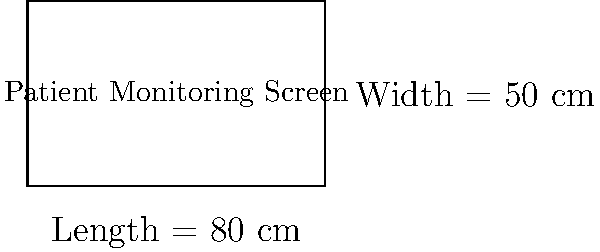A rectangular patient monitoring screen has a length of 80 cm and a width of 50 cm. Calculate the perimeter of the screen in meters. To calculate the perimeter of the rectangular patient monitoring screen, we need to follow these steps:

1. Recall the formula for the perimeter of a rectangle:
   $P = 2l + 2w$, where $P$ is the perimeter, $l$ is the length, and $w$ is the width.

2. Substitute the given values:
   $l = 80$ cm
   $w = 50$ cm

3. Apply the formula:
   $P = 2(80\text{ cm}) + 2(50\text{ cm})$
   $P = 160\text{ cm} + 100\text{ cm}$
   $P = 260\text{ cm}$

4. Convert the result from centimeters to meters:
   $260\text{ cm} = 2.60\text{ m}$

Therefore, the perimeter of the patient monitoring screen is 2.60 meters.
Answer: 2.60 m 